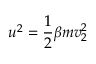<formula> <loc_0><loc_0><loc_500><loc_500>u ^ { 2 } = \frac { 1 } { 2 } \beta m v _ { 2 } ^ { 2 }</formula> 